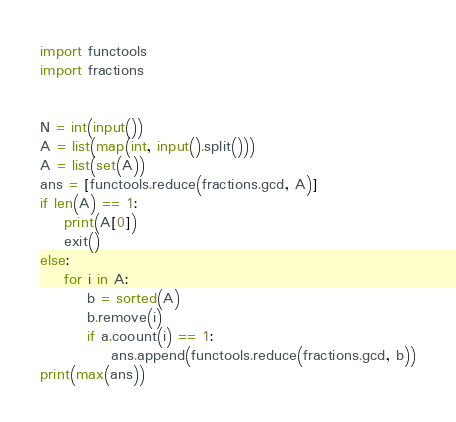<code> <loc_0><loc_0><loc_500><loc_500><_Python_>import functools
import fractions


N = int(input())
A = list(map(int, input().split()))
A = list(set(A))
ans = [functools.reduce(fractions.gcd, A)]
if len(A) == 1:
    print(A[0])
    exit()
else:
    for i in A:
        b = sorted(A)
        b.remove(i)
        if a.coount(i) == 1:
            ans.append(functools.reduce(fractions.gcd, b))
print(max(ans))</code> 